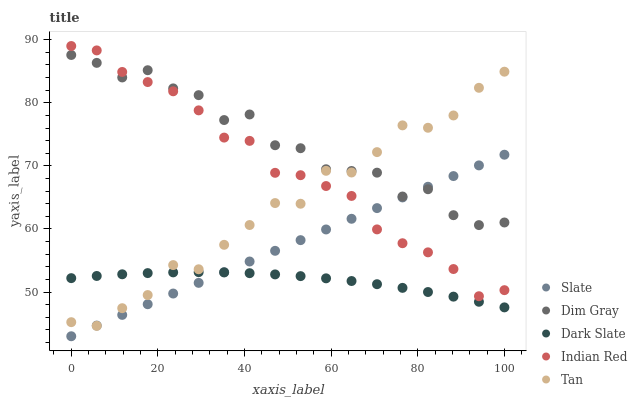Does Dark Slate have the minimum area under the curve?
Answer yes or no. Yes. Does Dim Gray have the maximum area under the curve?
Answer yes or no. Yes. Does Slate have the minimum area under the curve?
Answer yes or no. No. Does Slate have the maximum area under the curve?
Answer yes or no. No. Is Slate the smoothest?
Answer yes or no. Yes. Is Dim Gray the roughest?
Answer yes or no. Yes. Is Dim Gray the smoothest?
Answer yes or no. No. Is Slate the roughest?
Answer yes or no. No. Does Slate have the lowest value?
Answer yes or no. Yes. Does Dim Gray have the lowest value?
Answer yes or no. No. Does Indian Red have the highest value?
Answer yes or no. Yes. Does Slate have the highest value?
Answer yes or no. No. Is Dark Slate less than Indian Red?
Answer yes or no. Yes. Is Indian Red greater than Dark Slate?
Answer yes or no. Yes. Does Slate intersect Dark Slate?
Answer yes or no. Yes. Is Slate less than Dark Slate?
Answer yes or no. No. Is Slate greater than Dark Slate?
Answer yes or no. No. Does Dark Slate intersect Indian Red?
Answer yes or no. No. 